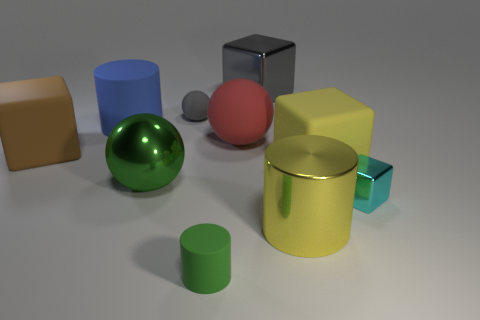Do the big yellow object behind the cyan object and the large green sphere have the same material?
Ensure brevity in your answer.  No. The green object in front of the cyan thing has what shape?
Give a very brief answer. Cylinder. Are the big green sphere and the large block to the left of the small green rubber cylinder made of the same material?
Give a very brief answer. No. Is the shape of the gray matte object the same as the red matte thing?
Provide a short and direct response. Yes. What is the material of the tiny cyan object that is the same shape as the big brown object?
Make the answer very short. Metal. What color is the thing that is to the left of the big green sphere and in front of the big blue cylinder?
Offer a very short reply. Brown. What is the color of the tiny block?
Provide a succinct answer. Cyan. What is the material of the object that is the same color as the tiny rubber cylinder?
Keep it short and to the point. Metal. Are there any red things that have the same shape as the green metallic object?
Offer a very short reply. Yes. There is a sphere behind the large red ball; what size is it?
Make the answer very short. Small. 